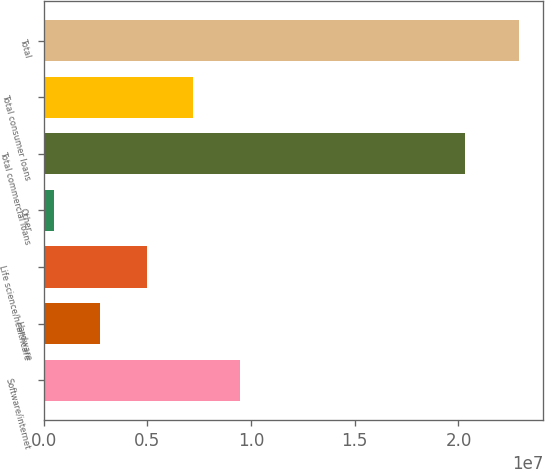Convert chart to OTSL. <chart><loc_0><loc_0><loc_500><loc_500><bar_chart><fcel>Software/internet<fcel>Hardware<fcel>Life science/healthcare<fcel>Other<fcel>Total commercial loans<fcel>Total consumer loans<fcel>Total<nl><fcel>9.45837e+06<fcel>2.72182e+06<fcel>4.96734e+06<fcel>476306<fcel>2.03046e+07<fcel>7.21285e+06<fcel>2.29315e+07<nl></chart> 